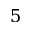Convert formula to latex. <formula><loc_0><loc_0><loc_500><loc_500>5</formula> 